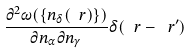<formula> <loc_0><loc_0><loc_500><loc_500>\frac { \partial ^ { 2 } \omega ( \{ n _ { \delta } ( \ r ) \} ) } { \partial n _ { \alpha } \partial n _ { \gamma } } \delta ( \ r - \ r ^ { \prime } )</formula> 